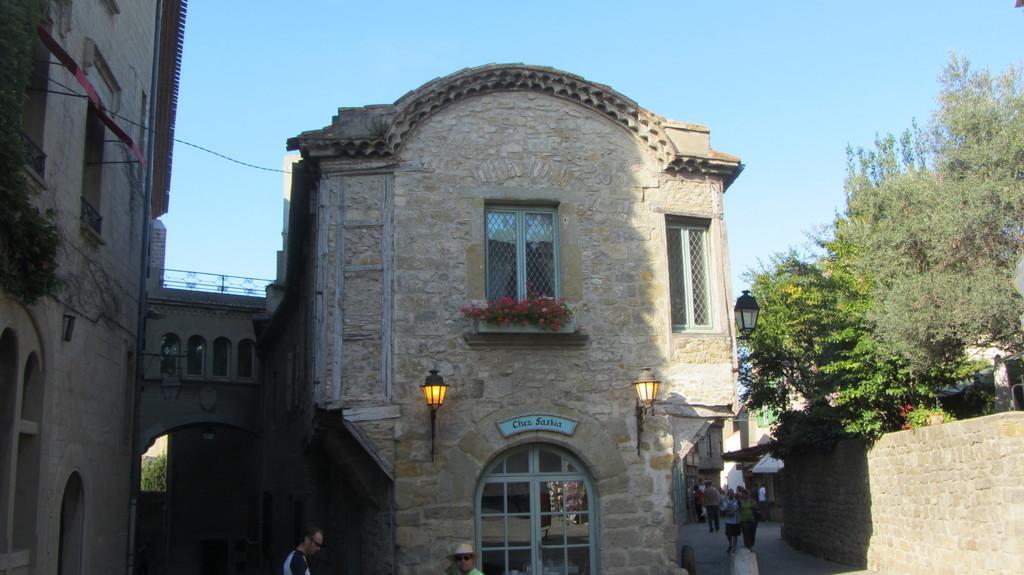Could you give a brief overview of what you see in this image? This picture shows couple of buildings and we see trees and few lights and we see people walking and a blue sky. 